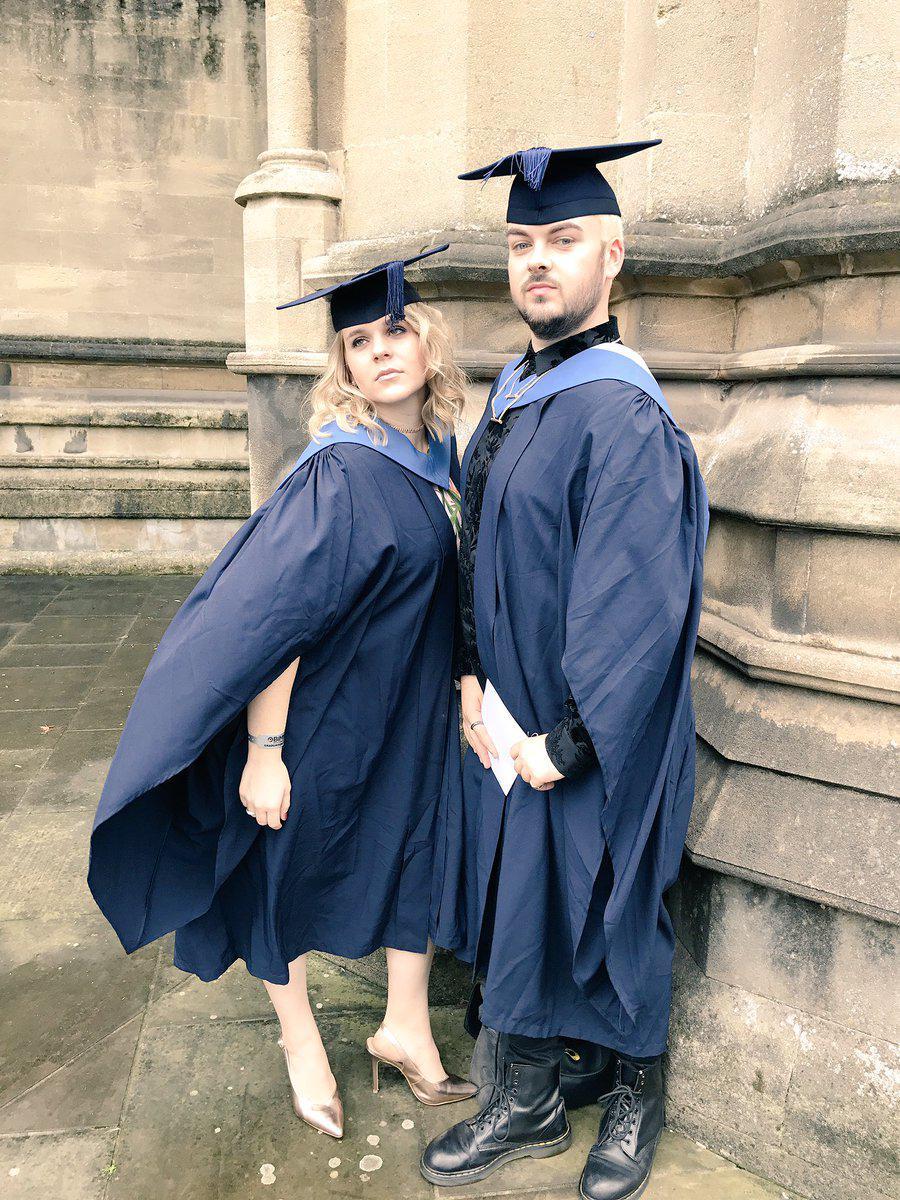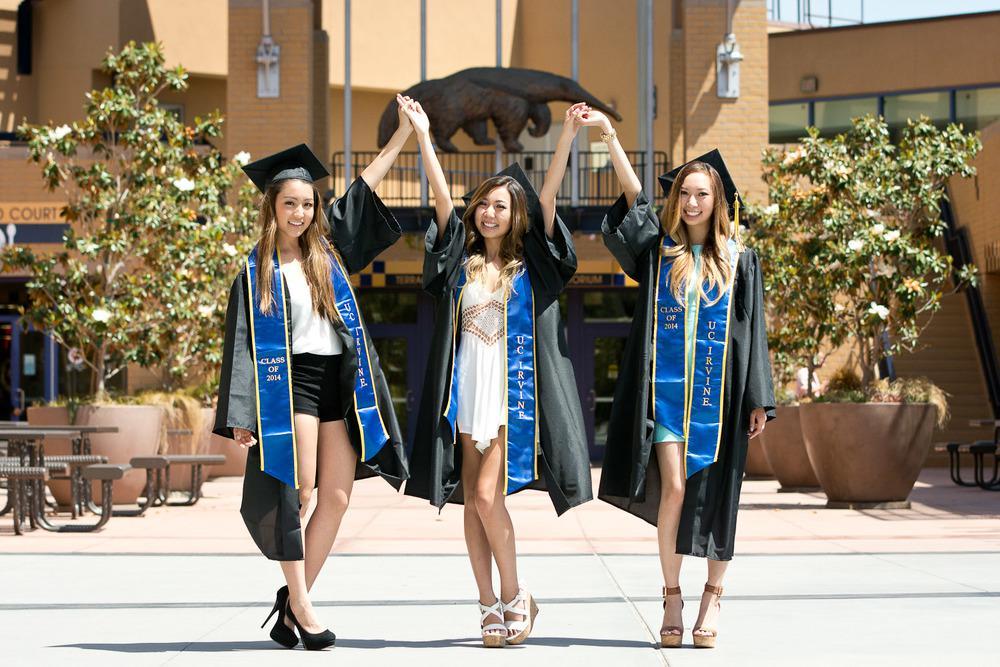The first image is the image on the left, the second image is the image on the right. Considering the images on both sides, is "An image shows exactly one male and one female graduate, wearing matching robes." valid? Answer yes or no. Yes. The first image is the image on the left, the second image is the image on the right. Assess this claim about the two images: "There is exactly three graduation students in the right image.". Correct or not? Answer yes or no. Yes. 